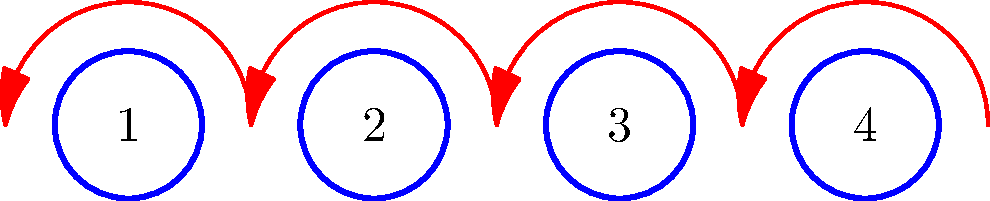In a Bollywood dance performance, four dancers are arranged in a line as shown in the diagram. The choreographer wants to create a new formation by having each dancer move to a different position. How many possible new arrangements can be created where no dancer remains in their original position? Let's approach this step-by-step:

1) This problem is an example of derangements in permutations. A derangement is a permutation where no element appears in its original position.

2) The total number of derangements for n elements is denoted by !n (subfactorial n).

3) The formula for calculating derangements is:

   $$!n = n! \sum_{k=0}^n \frac{(-1)^k}{k!}$$

4) For our case, n = 4. Let's calculate:

   $$!4 = 4! \sum_{k=0}^4 \frac{(-1)^k}{k!}$$

5) Expanding the sum:

   $$!4 = 24 \left(\frac{1}{0!} - \frac{1}{1!} + \frac{1}{2!} - \frac{1}{3!} + \frac{1}{4!}\right)$$

6) Calculating:

   $$!4 = 24 (1 - 1 + \frac{1}{2} - \frac{1}{6} + \frac{1}{24})$$
   $$!4 = 24 (\frac{9}{24}) = 9$$

Therefore, there are 9 possible new arrangements where no dancer remains in their original position.
Answer: 9 